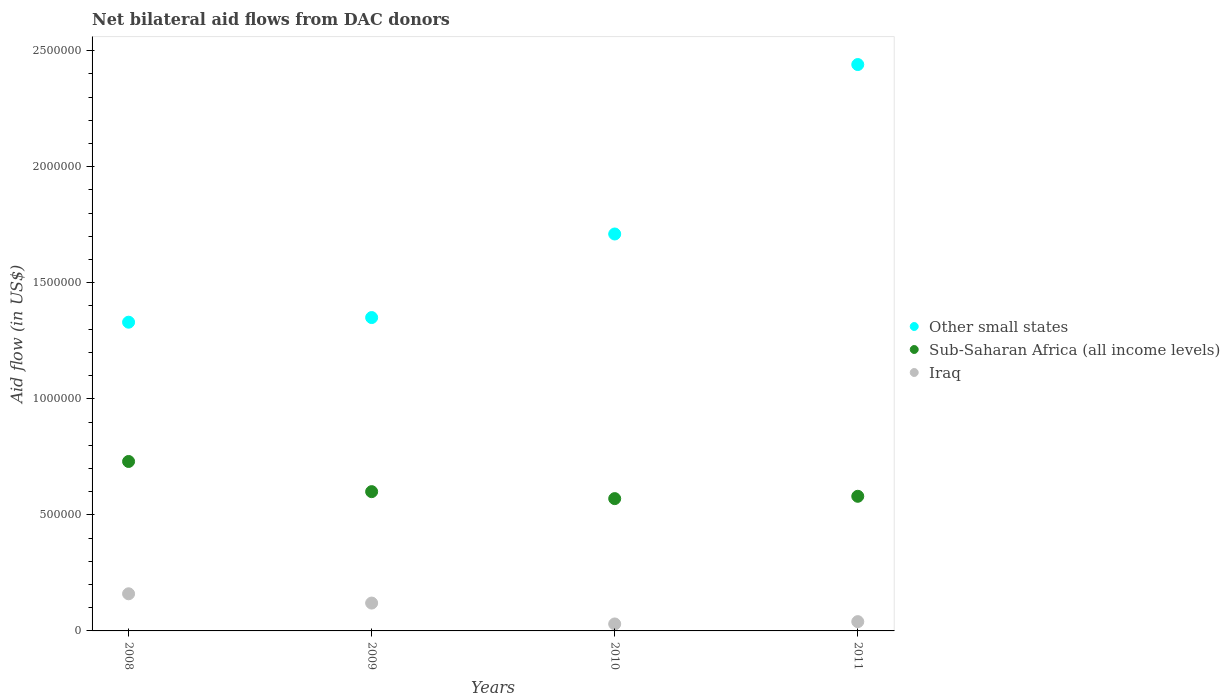What is the net bilateral aid flow in Iraq in 2008?
Offer a terse response. 1.60e+05. Across all years, what is the maximum net bilateral aid flow in Sub-Saharan Africa (all income levels)?
Offer a terse response. 7.30e+05. Across all years, what is the minimum net bilateral aid flow in Other small states?
Provide a short and direct response. 1.33e+06. In which year was the net bilateral aid flow in Iraq minimum?
Provide a short and direct response. 2010. What is the total net bilateral aid flow in Iraq in the graph?
Ensure brevity in your answer.  3.50e+05. What is the difference between the net bilateral aid flow in Other small states in 2008 and that in 2010?
Give a very brief answer. -3.80e+05. What is the difference between the net bilateral aid flow in Other small states in 2008 and the net bilateral aid flow in Sub-Saharan Africa (all income levels) in 2010?
Keep it short and to the point. 7.60e+05. What is the average net bilateral aid flow in Other small states per year?
Give a very brief answer. 1.71e+06. In the year 2008, what is the difference between the net bilateral aid flow in Sub-Saharan Africa (all income levels) and net bilateral aid flow in Iraq?
Offer a very short reply. 5.70e+05. What is the ratio of the net bilateral aid flow in Sub-Saharan Africa (all income levels) in 2009 to that in 2010?
Provide a succinct answer. 1.05. What is the difference between the highest and the second highest net bilateral aid flow in Other small states?
Your answer should be very brief. 7.30e+05. What is the difference between the highest and the lowest net bilateral aid flow in Sub-Saharan Africa (all income levels)?
Offer a very short reply. 1.60e+05. In how many years, is the net bilateral aid flow in Iraq greater than the average net bilateral aid flow in Iraq taken over all years?
Make the answer very short. 2. Is the sum of the net bilateral aid flow in Iraq in 2008 and 2011 greater than the maximum net bilateral aid flow in Sub-Saharan Africa (all income levels) across all years?
Provide a short and direct response. No. Is it the case that in every year, the sum of the net bilateral aid flow in Other small states and net bilateral aid flow in Iraq  is greater than the net bilateral aid flow in Sub-Saharan Africa (all income levels)?
Offer a terse response. Yes. Is the net bilateral aid flow in Iraq strictly greater than the net bilateral aid flow in Sub-Saharan Africa (all income levels) over the years?
Provide a short and direct response. No. How many dotlines are there?
Provide a short and direct response. 3. How many years are there in the graph?
Make the answer very short. 4. Are the values on the major ticks of Y-axis written in scientific E-notation?
Ensure brevity in your answer.  No. Does the graph contain any zero values?
Give a very brief answer. No. How many legend labels are there?
Ensure brevity in your answer.  3. How are the legend labels stacked?
Keep it short and to the point. Vertical. What is the title of the graph?
Your response must be concise. Net bilateral aid flows from DAC donors. What is the label or title of the Y-axis?
Provide a short and direct response. Aid flow (in US$). What is the Aid flow (in US$) of Other small states in 2008?
Give a very brief answer. 1.33e+06. What is the Aid flow (in US$) of Sub-Saharan Africa (all income levels) in 2008?
Offer a very short reply. 7.30e+05. What is the Aid flow (in US$) of Other small states in 2009?
Your response must be concise. 1.35e+06. What is the Aid flow (in US$) of Other small states in 2010?
Make the answer very short. 1.71e+06. What is the Aid flow (in US$) in Sub-Saharan Africa (all income levels) in 2010?
Offer a terse response. 5.70e+05. What is the Aid flow (in US$) in Other small states in 2011?
Provide a short and direct response. 2.44e+06. What is the Aid flow (in US$) in Sub-Saharan Africa (all income levels) in 2011?
Provide a short and direct response. 5.80e+05. What is the Aid flow (in US$) of Iraq in 2011?
Provide a short and direct response. 4.00e+04. Across all years, what is the maximum Aid flow (in US$) in Other small states?
Keep it short and to the point. 2.44e+06. Across all years, what is the maximum Aid flow (in US$) of Sub-Saharan Africa (all income levels)?
Make the answer very short. 7.30e+05. Across all years, what is the minimum Aid flow (in US$) in Other small states?
Your answer should be very brief. 1.33e+06. Across all years, what is the minimum Aid flow (in US$) of Sub-Saharan Africa (all income levels)?
Your response must be concise. 5.70e+05. Across all years, what is the minimum Aid flow (in US$) of Iraq?
Your response must be concise. 3.00e+04. What is the total Aid flow (in US$) in Other small states in the graph?
Ensure brevity in your answer.  6.83e+06. What is the total Aid flow (in US$) of Sub-Saharan Africa (all income levels) in the graph?
Your answer should be compact. 2.48e+06. What is the total Aid flow (in US$) of Iraq in the graph?
Your answer should be very brief. 3.50e+05. What is the difference between the Aid flow (in US$) of Sub-Saharan Africa (all income levels) in 2008 and that in 2009?
Your response must be concise. 1.30e+05. What is the difference between the Aid flow (in US$) of Iraq in 2008 and that in 2009?
Your answer should be compact. 4.00e+04. What is the difference between the Aid flow (in US$) of Other small states in 2008 and that in 2010?
Keep it short and to the point. -3.80e+05. What is the difference between the Aid flow (in US$) of Sub-Saharan Africa (all income levels) in 2008 and that in 2010?
Offer a terse response. 1.60e+05. What is the difference between the Aid flow (in US$) of Iraq in 2008 and that in 2010?
Your response must be concise. 1.30e+05. What is the difference between the Aid flow (in US$) in Other small states in 2008 and that in 2011?
Your response must be concise. -1.11e+06. What is the difference between the Aid flow (in US$) in Sub-Saharan Africa (all income levels) in 2008 and that in 2011?
Offer a terse response. 1.50e+05. What is the difference between the Aid flow (in US$) in Other small states in 2009 and that in 2010?
Offer a very short reply. -3.60e+05. What is the difference between the Aid flow (in US$) in Other small states in 2009 and that in 2011?
Your answer should be compact. -1.09e+06. What is the difference between the Aid flow (in US$) of Sub-Saharan Africa (all income levels) in 2009 and that in 2011?
Make the answer very short. 2.00e+04. What is the difference between the Aid flow (in US$) of Other small states in 2010 and that in 2011?
Your answer should be very brief. -7.30e+05. What is the difference between the Aid flow (in US$) of Sub-Saharan Africa (all income levels) in 2010 and that in 2011?
Keep it short and to the point. -10000. What is the difference between the Aid flow (in US$) in Iraq in 2010 and that in 2011?
Keep it short and to the point. -10000. What is the difference between the Aid flow (in US$) of Other small states in 2008 and the Aid flow (in US$) of Sub-Saharan Africa (all income levels) in 2009?
Give a very brief answer. 7.30e+05. What is the difference between the Aid flow (in US$) in Other small states in 2008 and the Aid flow (in US$) in Iraq in 2009?
Give a very brief answer. 1.21e+06. What is the difference between the Aid flow (in US$) of Other small states in 2008 and the Aid flow (in US$) of Sub-Saharan Africa (all income levels) in 2010?
Give a very brief answer. 7.60e+05. What is the difference between the Aid flow (in US$) of Other small states in 2008 and the Aid flow (in US$) of Iraq in 2010?
Your response must be concise. 1.30e+06. What is the difference between the Aid flow (in US$) in Other small states in 2008 and the Aid flow (in US$) in Sub-Saharan Africa (all income levels) in 2011?
Provide a succinct answer. 7.50e+05. What is the difference between the Aid flow (in US$) of Other small states in 2008 and the Aid flow (in US$) of Iraq in 2011?
Your answer should be compact. 1.29e+06. What is the difference between the Aid flow (in US$) in Sub-Saharan Africa (all income levels) in 2008 and the Aid flow (in US$) in Iraq in 2011?
Offer a terse response. 6.90e+05. What is the difference between the Aid flow (in US$) of Other small states in 2009 and the Aid flow (in US$) of Sub-Saharan Africa (all income levels) in 2010?
Your response must be concise. 7.80e+05. What is the difference between the Aid flow (in US$) of Other small states in 2009 and the Aid flow (in US$) of Iraq in 2010?
Your answer should be compact. 1.32e+06. What is the difference between the Aid flow (in US$) of Sub-Saharan Africa (all income levels) in 2009 and the Aid flow (in US$) of Iraq in 2010?
Your answer should be very brief. 5.70e+05. What is the difference between the Aid flow (in US$) in Other small states in 2009 and the Aid flow (in US$) in Sub-Saharan Africa (all income levels) in 2011?
Your answer should be compact. 7.70e+05. What is the difference between the Aid flow (in US$) of Other small states in 2009 and the Aid flow (in US$) of Iraq in 2011?
Offer a very short reply. 1.31e+06. What is the difference between the Aid flow (in US$) of Sub-Saharan Africa (all income levels) in 2009 and the Aid flow (in US$) of Iraq in 2011?
Keep it short and to the point. 5.60e+05. What is the difference between the Aid flow (in US$) in Other small states in 2010 and the Aid flow (in US$) in Sub-Saharan Africa (all income levels) in 2011?
Your response must be concise. 1.13e+06. What is the difference between the Aid flow (in US$) in Other small states in 2010 and the Aid flow (in US$) in Iraq in 2011?
Offer a very short reply. 1.67e+06. What is the difference between the Aid flow (in US$) of Sub-Saharan Africa (all income levels) in 2010 and the Aid flow (in US$) of Iraq in 2011?
Provide a succinct answer. 5.30e+05. What is the average Aid flow (in US$) of Other small states per year?
Make the answer very short. 1.71e+06. What is the average Aid flow (in US$) of Sub-Saharan Africa (all income levels) per year?
Offer a terse response. 6.20e+05. What is the average Aid flow (in US$) of Iraq per year?
Make the answer very short. 8.75e+04. In the year 2008, what is the difference between the Aid flow (in US$) in Other small states and Aid flow (in US$) in Sub-Saharan Africa (all income levels)?
Provide a short and direct response. 6.00e+05. In the year 2008, what is the difference between the Aid flow (in US$) of Other small states and Aid flow (in US$) of Iraq?
Provide a succinct answer. 1.17e+06. In the year 2008, what is the difference between the Aid flow (in US$) of Sub-Saharan Africa (all income levels) and Aid flow (in US$) of Iraq?
Give a very brief answer. 5.70e+05. In the year 2009, what is the difference between the Aid flow (in US$) of Other small states and Aid flow (in US$) of Sub-Saharan Africa (all income levels)?
Your answer should be very brief. 7.50e+05. In the year 2009, what is the difference between the Aid flow (in US$) in Other small states and Aid flow (in US$) in Iraq?
Give a very brief answer. 1.23e+06. In the year 2009, what is the difference between the Aid flow (in US$) of Sub-Saharan Africa (all income levels) and Aid flow (in US$) of Iraq?
Ensure brevity in your answer.  4.80e+05. In the year 2010, what is the difference between the Aid flow (in US$) in Other small states and Aid flow (in US$) in Sub-Saharan Africa (all income levels)?
Your answer should be compact. 1.14e+06. In the year 2010, what is the difference between the Aid flow (in US$) of Other small states and Aid flow (in US$) of Iraq?
Provide a succinct answer. 1.68e+06. In the year 2010, what is the difference between the Aid flow (in US$) of Sub-Saharan Africa (all income levels) and Aid flow (in US$) of Iraq?
Your answer should be very brief. 5.40e+05. In the year 2011, what is the difference between the Aid flow (in US$) in Other small states and Aid flow (in US$) in Sub-Saharan Africa (all income levels)?
Give a very brief answer. 1.86e+06. In the year 2011, what is the difference between the Aid flow (in US$) in Other small states and Aid flow (in US$) in Iraq?
Ensure brevity in your answer.  2.40e+06. In the year 2011, what is the difference between the Aid flow (in US$) in Sub-Saharan Africa (all income levels) and Aid flow (in US$) in Iraq?
Offer a very short reply. 5.40e+05. What is the ratio of the Aid flow (in US$) of Other small states in 2008 to that in 2009?
Offer a terse response. 0.99. What is the ratio of the Aid flow (in US$) of Sub-Saharan Africa (all income levels) in 2008 to that in 2009?
Keep it short and to the point. 1.22. What is the ratio of the Aid flow (in US$) in Sub-Saharan Africa (all income levels) in 2008 to that in 2010?
Offer a very short reply. 1.28. What is the ratio of the Aid flow (in US$) of Iraq in 2008 to that in 2010?
Give a very brief answer. 5.33. What is the ratio of the Aid flow (in US$) of Other small states in 2008 to that in 2011?
Provide a succinct answer. 0.55. What is the ratio of the Aid flow (in US$) of Sub-Saharan Africa (all income levels) in 2008 to that in 2011?
Offer a very short reply. 1.26. What is the ratio of the Aid flow (in US$) in Iraq in 2008 to that in 2011?
Offer a terse response. 4. What is the ratio of the Aid flow (in US$) in Other small states in 2009 to that in 2010?
Provide a succinct answer. 0.79. What is the ratio of the Aid flow (in US$) of Sub-Saharan Africa (all income levels) in 2009 to that in 2010?
Provide a succinct answer. 1.05. What is the ratio of the Aid flow (in US$) in Iraq in 2009 to that in 2010?
Make the answer very short. 4. What is the ratio of the Aid flow (in US$) in Other small states in 2009 to that in 2011?
Offer a very short reply. 0.55. What is the ratio of the Aid flow (in US$) in Sub-Saharan Africa (all income levels) in 2009 to that in 2011?
Ensure brevity in your answer.  1.03. What is the ratio of the Aid flow (in US$) of Iraq in 2009 to that in 2011?
Ensure brevity in your answer.  3. What is the ratio of the Aid flow (in US$) of Other small states in 2010 to that in 2011?
Your response must be concise. 0.7. What is the ratio of the Aid flow (in US$) in Sub-Saharan Africa (all income levels) in 2010 to that in 2011?
Keep it short and to the point. 0.98. What is the ratio of the Aid flow (in US$) in Iraq in 2010 to that in 2011?
Your response must be concise. 0.75. What is the difference between the highest and the second highest Aid flow (in US$) of Other small states?
Offer a terse response. 7.30e+05. What is the difference between the highest and the second highest Aid flow (in US$) in Sub-Saharan Africa (all income levels)?
Give a very brief answer. 1.30e+05. What is the difference between the highest and the second highest Aid flow (in US$) in Iraq?
Your answer should be compact. 4.00e+04. What is the difference between the highest and the lowest Aid flow (in US$) of Other small states?
Provide a short and direct response. 1.11e+06. What is the difference between the highest and the lowest Aid flow (in US$) of Sub-Saharan Africa (all income levels)?
Offer a very short reply. 1.60e+05. 